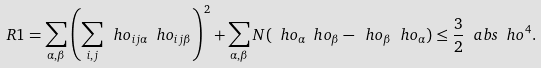<formula> <loc_0><loc_0><loc_500><loc_500>R 1 = \sum _ { \alpha , \beta } \left ( \sum _ { i , j } \ h o _ { i j \alpha } \ h o _ { i j \beta } \right ) ^ { 2 } + \sum _ { \alpha , \beta } N ( \ h o _ { \alpha } \ h o _ { \beta } - \ h o _ { \beta } \ h o _ { \alpha } ) \leq \frac { 3 } { 2 } \ a b s { \ h o } ^ { 4 } .</formula> 